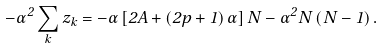<formula> <loc_0><loc_0><loc_500><loc_500>- \alpha ^ { 2 } \sum _ { k } z _ { k } = - \alpha \left [ 2 A + \left ( 2 p + 1 \right ) \alpha \right ] N - \alpha ^ { 2 } N \left ( N - 1 \right ) .</formula> 